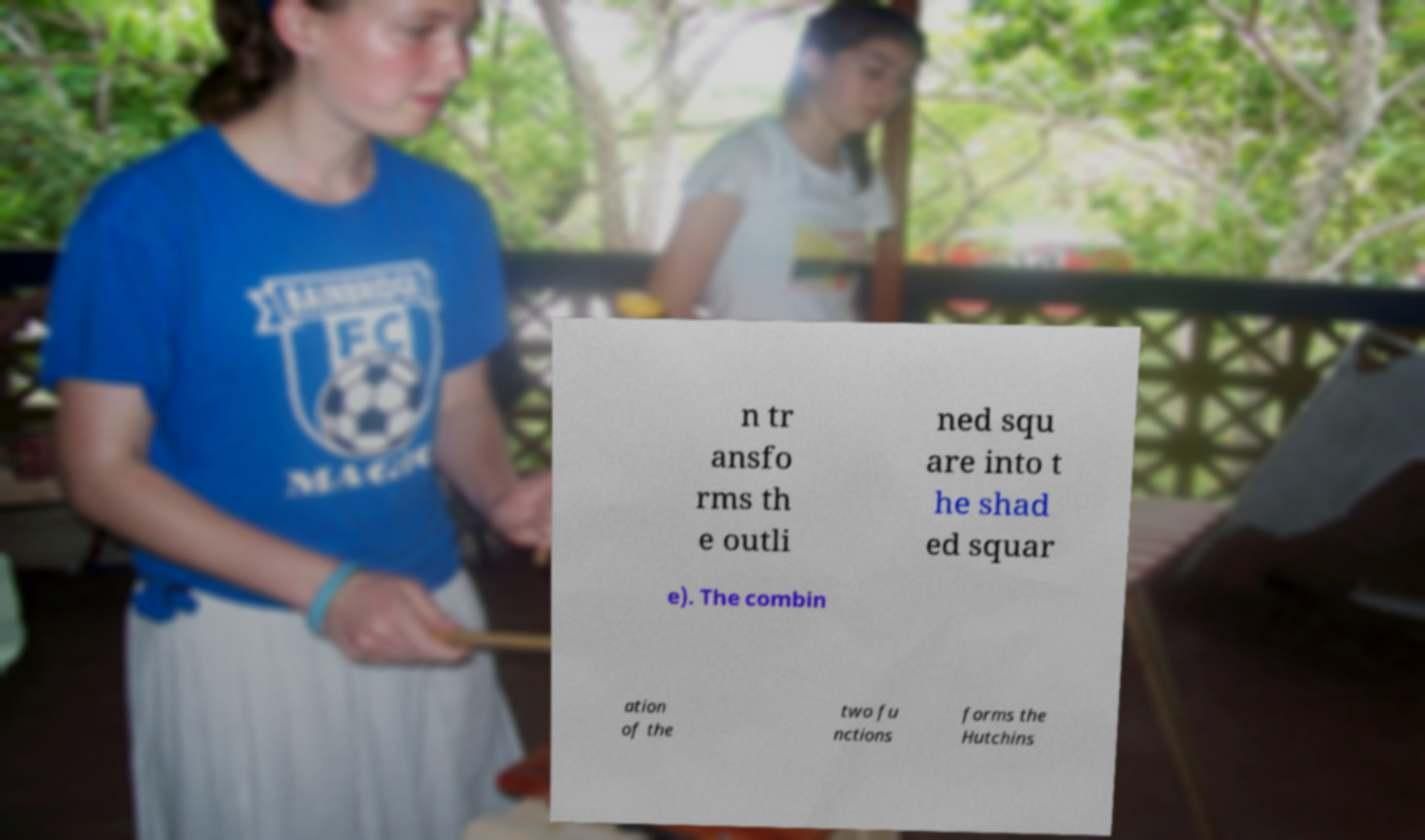I need the written content from this picture converted into text. Can you do that? n tr ansfo rms th e outli ned squ are into t he shad ed squar e). The combin ation of the two fu nctions forms the Hutchins 